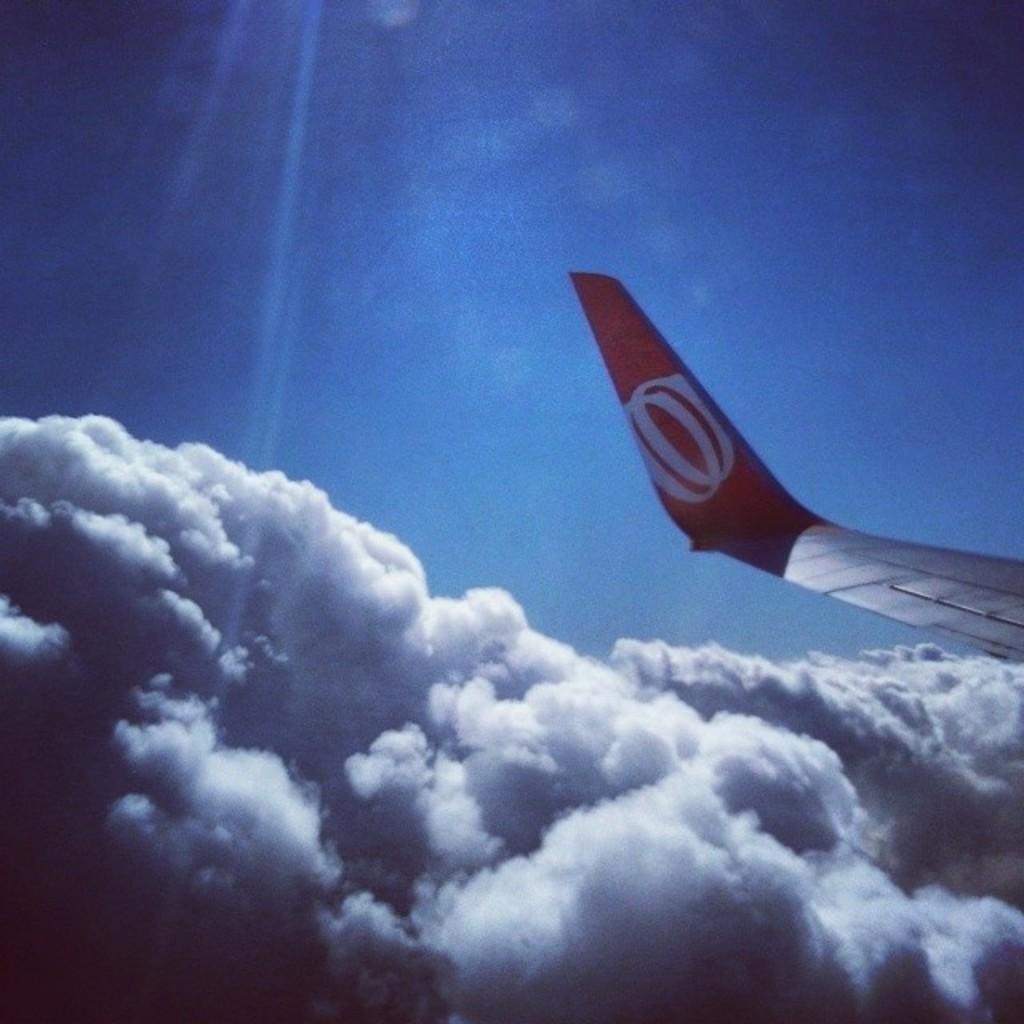How would you summarize this image in a sentence or two? On the right side we can see a tail of a flight. In the background there is sky with clouds. 